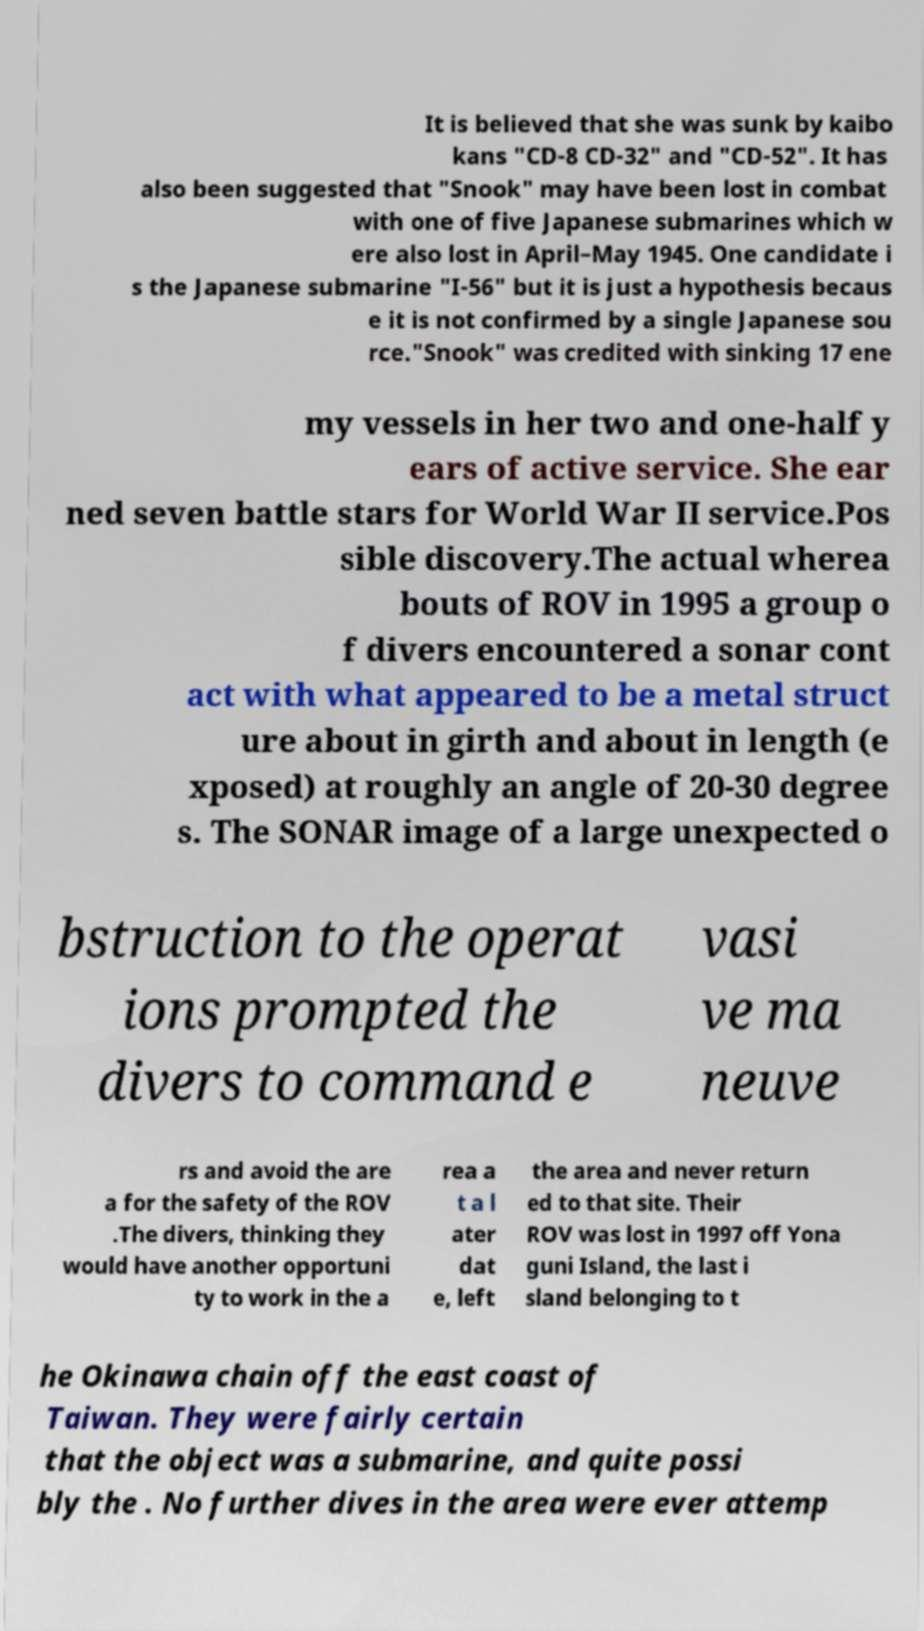There's text embedded in this image that I need extracted. Can you transcribe it verbatim? It is believed that she was sunk by kaibo kans "CD-8 CD-32" and "CD-52". It has also been suggested that "Snook" may have been lost in combat with one of five Japanese submarines which w ere also lost in April–May 1945. One candidate i s the Japanese submarine "I-56" but it is just a hypothesis becaus e it is not confirmed by a single Japanese sou rce."Snook" was credited with sinking 17 ene my vessels in her two and one-half y ears of active service. She ear ned seven battle stars for World War II service.Pos sible discovery.The actual wherea bouts of ROV in 1995 a group o f divers encountered a sonar cont act with what appeared to be a metal struct ure about in girth and about in length (e xposed) at roughly an angle of 20-30 degree s. The SONAR image of a large unexpected o bstruction to the operat ions prompted the divers to command e vasi ve ma neuve rs and avoid the are a for the safety of the ROV .The divers, thinking they would have another opportuni ty to work in the a rea a t a l ater dat e, left the area and never return ed to that site. Their ROV was lost in 1997 off Yona guni Island, the last i sland belonging to t he Okinawa chain off the east coast of Taiwan. They were fairly certain that the object was a submarine, and quite possi bly the . No further dives in the area were ever attemp 